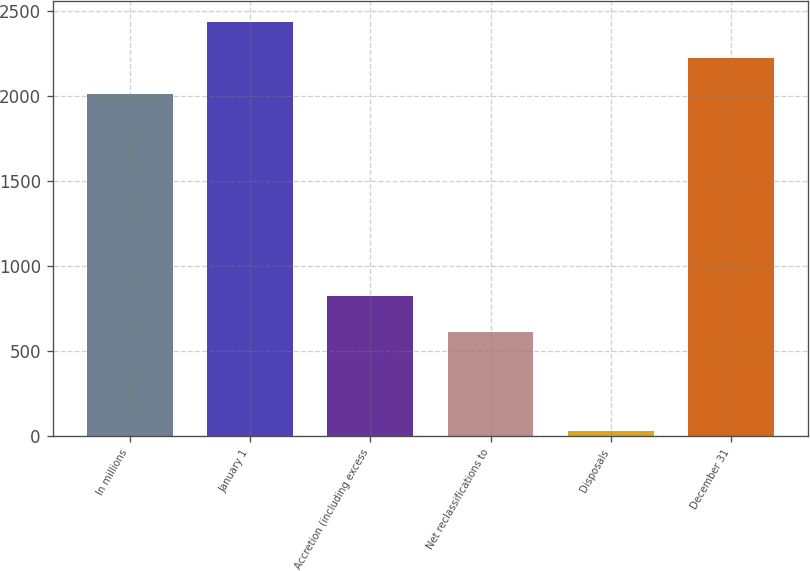<chart> <loc_0><loc_0><loc_500><loc_500><bar_chart><fcel>In millions<fcel>January 1<fcel>Accretion (including excess<fcel>Net reclassifications to<fcel>Disposals<fcel>December 31<nl><fcel>2013<fcel>2440.4<fcel>826.7<fcel>613<fcel>29<fcel>2226.7<nl></chart> 